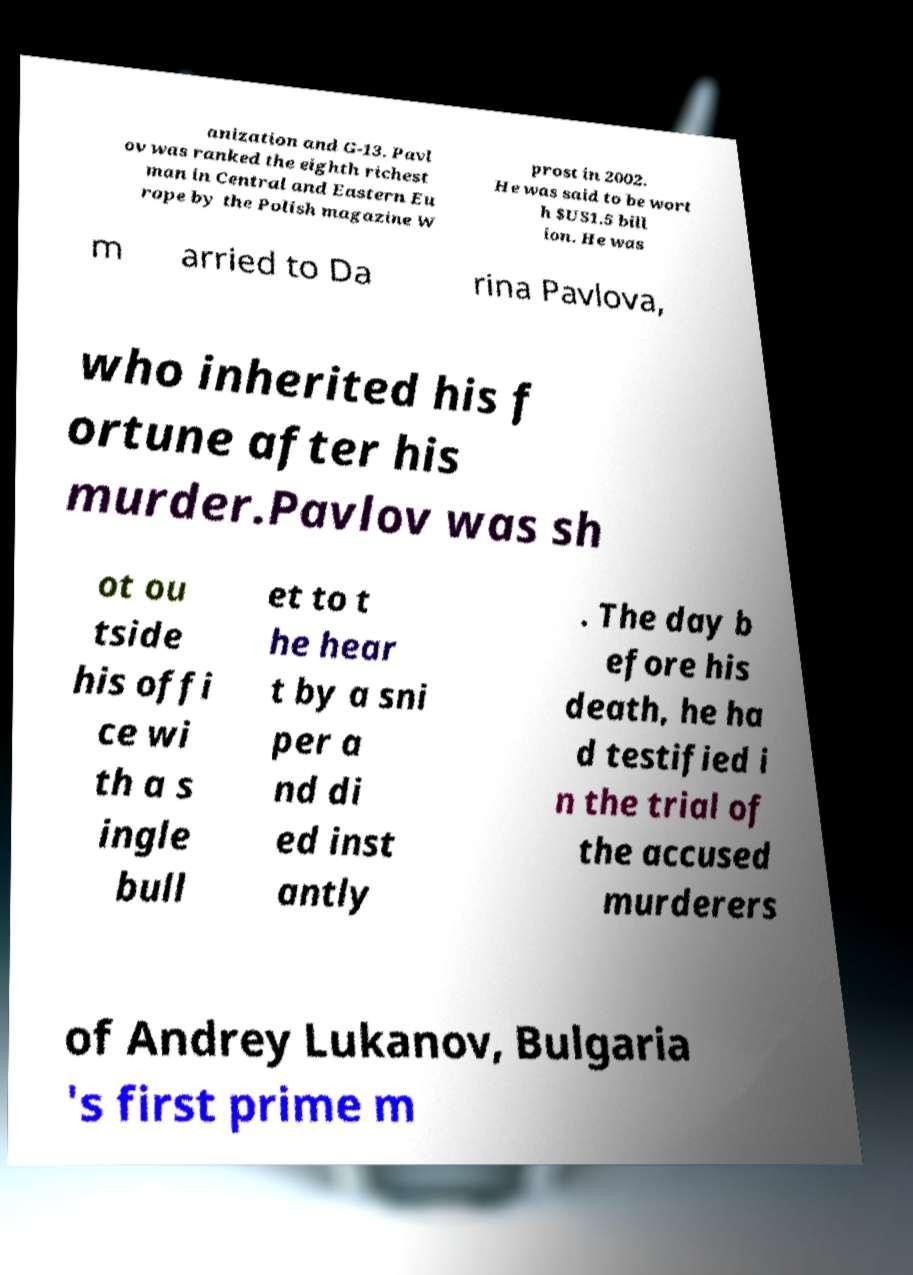There's text embedded in this image that I need extracted. Can you transcribe it verbatim? anization and G-13. Pavl ov was ranked the eighth richest man in Central and Eastern Eu rope by the Polish magazine W prost in 2002. He was said to be wort h $US1.5 bill ion. He was m arried to Da rina Pavlova, who inherited his f ortune after his murder.Pavlov was sh ot ou tside his offi ce wi th a s ingle bull et to t he hear t by a sni per a nd di ed inst antly . The day b efore his death, he ha d testified i n the trial of the accused murderers of Andrey Lukanov, Bulgaria 's first prime m 